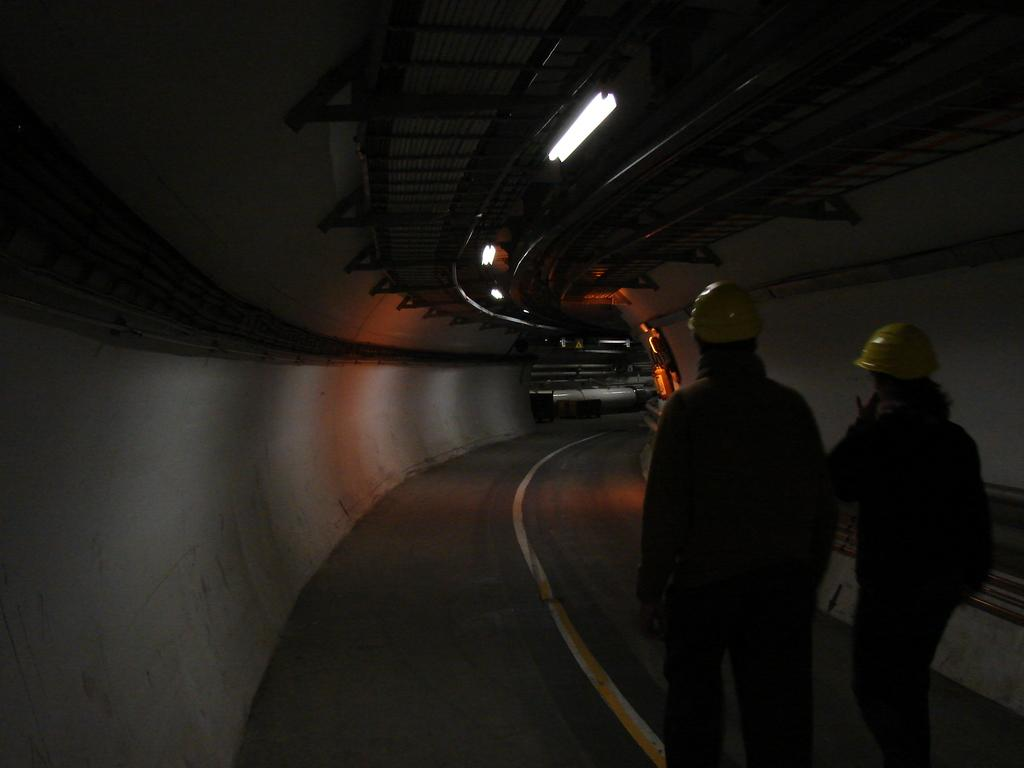Who can be seen on the right side of the image? There are two people on the right side of the image. What are the people wearing on their heads? The people are wearing helmets. What is at the bottom of the image? There is a road at the bottom of the image. What can be seen in the background of the image? There are walls and lights in the background of the image. What type of pen is being used for distribution in the image? There is no pen or distribution activity present in the image. What is the name of the person on the left side of the image? There is no person on the left side of the image, as the two people are on the right side. 